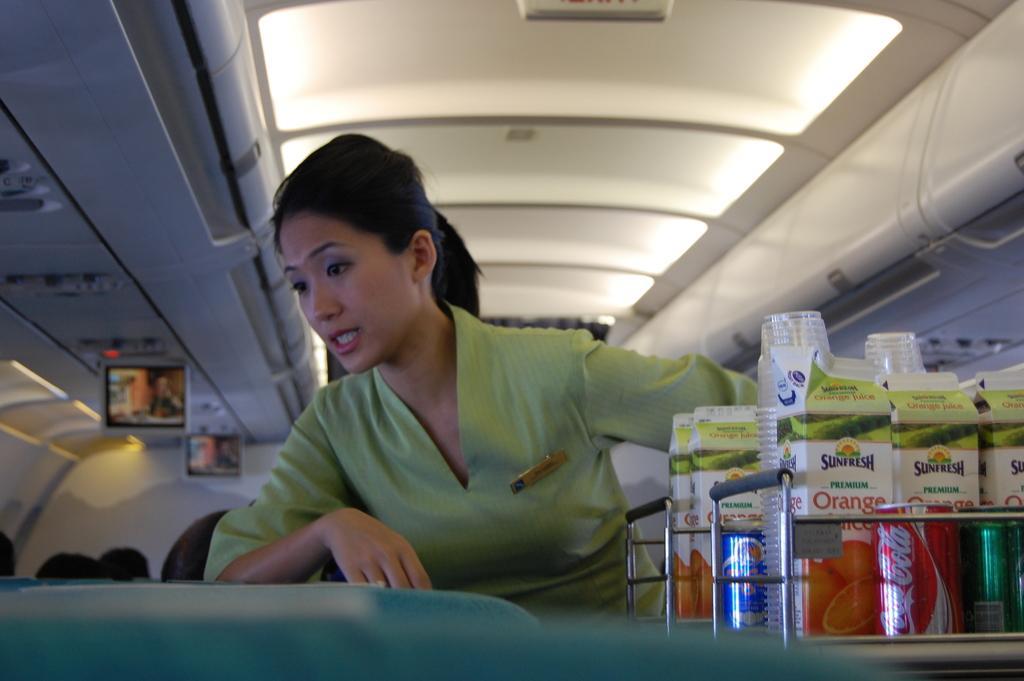How would you summarize this image in a sentence or two? In this image I can see a person standing wearing green dress, in front I can see few glasses, tins. At the back I can see wall in white color and few screens. 